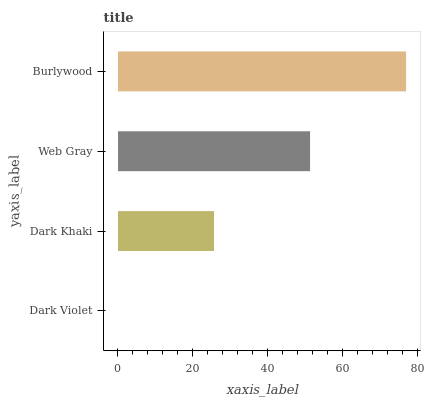Is Dark Violet the minimum?
Answer yes or no. Yes. Is Burlywood the maximum?
Answer yes or no. Yes. Is Dark Khaki the minimum?
Answer yes or no. No. Is Dark Khaki the maximum?
Answer yes or no. No. Is Dark Khaki greater than Dark Violet?
Answer yes or no. Yes. Is Dark Violet less than Dark Khaki?
Answer yes or no. Yes. Is Dark Violet greater than Dark Khaki?
Answer yes or no. No. Is Dark Khaki less than Dark Violet?
Answer yes or no. No. Is Web Gray the high median?
Answer yes or no. Yes. Is Dark Khaki the low median?
Answer yes or no. Yes. Is Burlywood the high median?
Answer yes or no. No. Is Burlywood the low median?
Answer yes or no. No. 